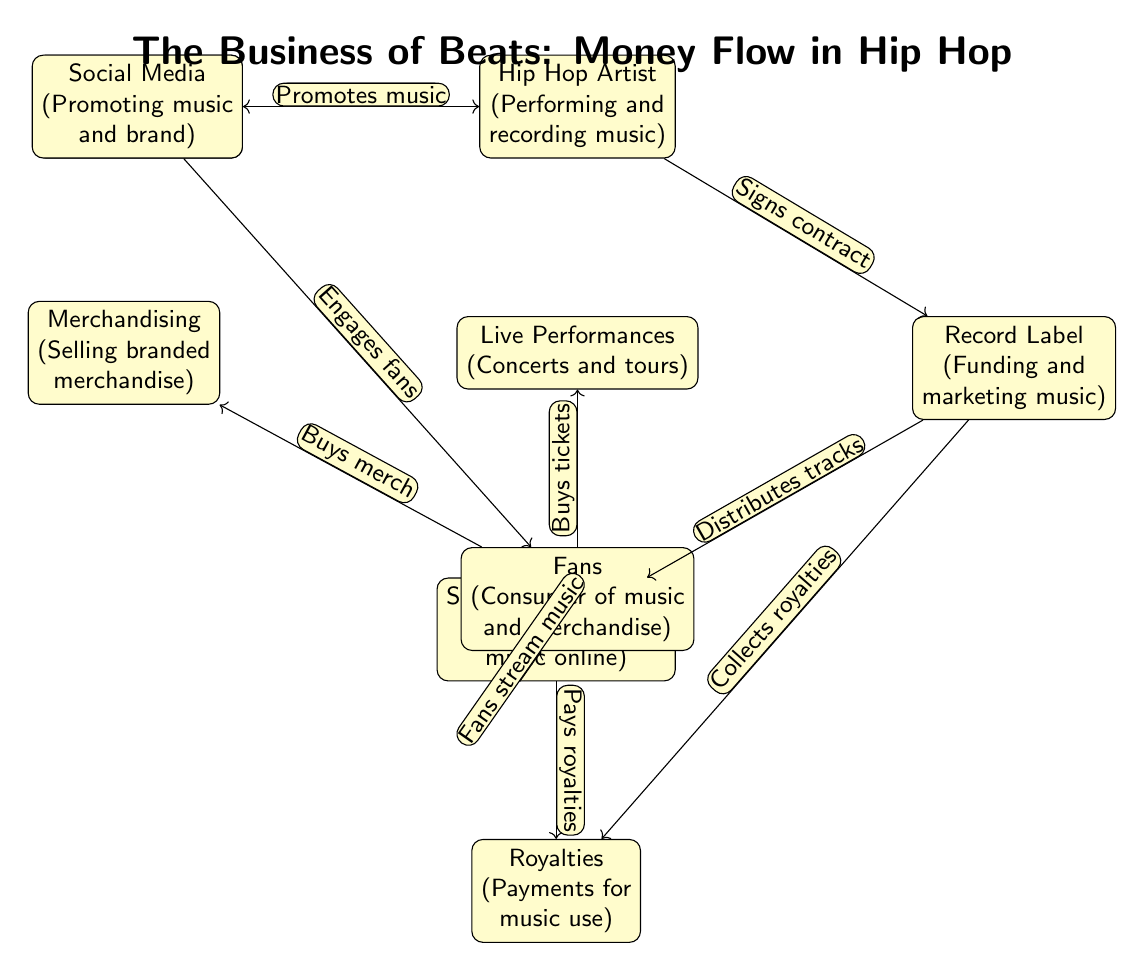What is the starting point of the music flow? The starting point is the Music Production node, which is where beats and tracks are created.
Answer: Music Production Which node connects Hip Hop Artist and Record Label? The edge from the Hip Hop Artist to the Record Label indicates that the artist signs a contract with the label.
Answer: Signs contract How many nodes represent revenue generation activities? The diagram shows three nodes related to revenue: Royalties, Live Performances, and Merchandising.
Answer: Three What action leads Fans to buy concert tickets? The action represented is "Fans stream music," which indicates that by engaging with the music, fans are motivated to buy tickets for live performances.
Answer: Fans stream music Which node promotes music and engages fans? The Social Media node is responsible for promoting music and engaging fans through various online platforms.
Answer: Social Media What two nodes connect directly to the Royalties node? The Royalties node is connected directly to the Record Label (which collects royalties) and Streaming Platforms (which pays royalties).
Answer: Record Label, Streaming Platforms How does the Streaming Platforms node contribute to revenue? The Streaming Platforms node generates revenue by distributing music online and paying royalties based on music usage.
Answer: Pays royalties What connection exists between Fans and Merchandising? Fans engage with merchandise by purchasing branded items, indicating a direct relationship where fans buy merch.
Answer: Buys merch Which two activities fall under the responsibility of the Record Label? The Record Label is responsible for funding and marketing music as well as distributing tracks.
Answer: Funding, marketing 